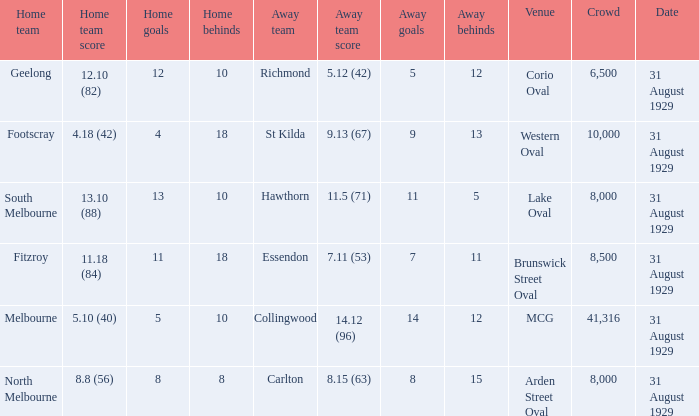What was the score of the home team when the away team scored 14.12 (96)? 5.10 (40). 